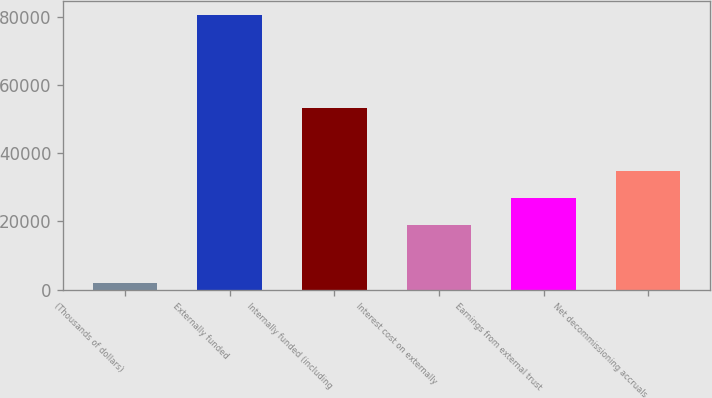<chart> <loc_0><loc_0><loc_500><loc_500><bar_chart><fcel>(Thousands of dollars)<fcel>Externally funded<fcel>Internally funded (including<fcel>Interest cost on externally<fcel>Earnings from external trust<fcel>Net decommissioning accruals<nl><fcel>2004<fcel>80582<fcel>53307<fcel>19026<fcel>26883.8<fcel>34741.6<nl></chart> 